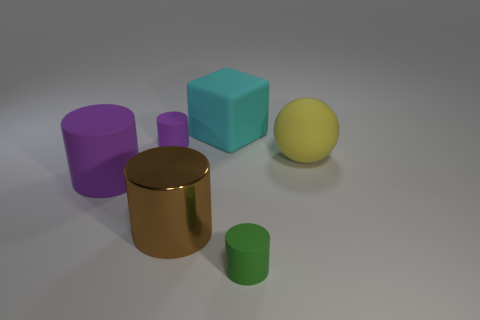Subtract all green cylinders. How many cylinders are left? 3 Subtract all big brown metal cylinders. How many cylinders are left? 3 Subtract all yellow cylinders. Subtract all blue spheres. How many cylinders are left? 4 Add 3 tiny red shiny balls. How many objects exist? 9 Subtract all cylinders. How many objects are left? 2 Subtract 0 red spheres. How many objects are left? 6 Subtract all large cyan matte objects. Subtract all big shiny things. How many objects are left? 4 Add 4 large brown cylinders. How many large brown cylinders are left? 5 Add 2 small metallic things. How many small metallic things exist? 2 